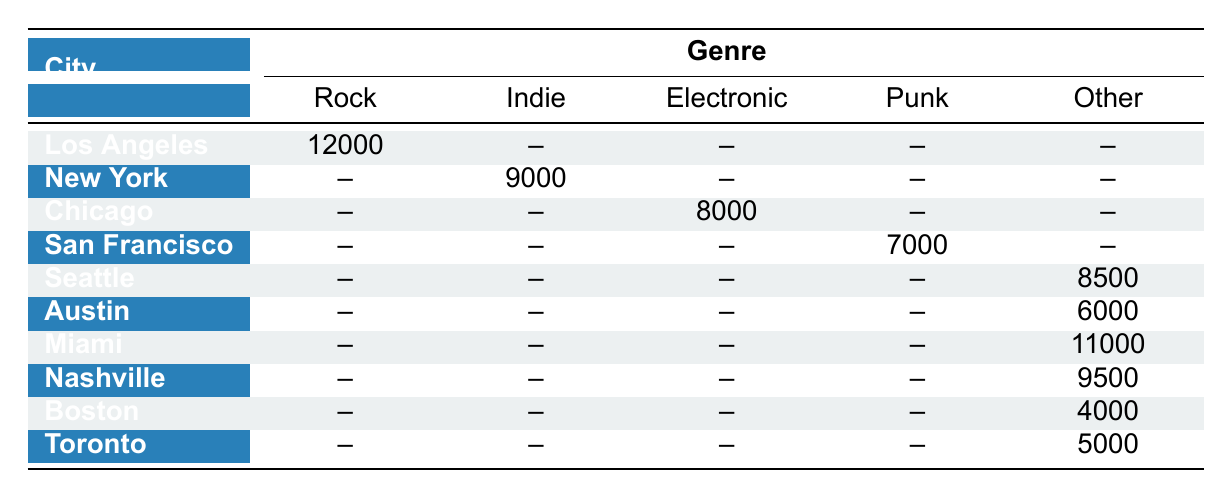What is the concert attendance for Los Angeles in the Rock genre? According to the table, Los Angeles has an attendance of 12000 for the Rock genre.
Answer: 12000 Which city had the lowest concert attendance? By looking at the table, Boston had the lowest attendance with 4000.
Answer: 4000 Is there any city listed for the Punk genre? Yes, San Francisco is the only city listed for the Punk genre, with an attendance of 7000.
Answer: Yes What is the total concert attendance for cities that have genres listed as 'Other'? Only two entries fall under the 'Other' category: Seattle (8500) and Austin (6000), summing these gives 8500 + 6000 = 14500.
Answer: 14500 Which city had higher attendance: Miami or Nashville? Miami had an attendance of 11000, while Nashville had 9500. Therefore, Miami had higher attendance.
Answer: Miami What is the difference in attendance between New York's Indie and Miami's Hip-Hop genre? New York's attendance is 9000 for the Indie genre, and Miami's is 11000 for Hip-Hop. The difference is 11000 - 9000 = 2000.
Answer: 2000 Are there any cities with an attendance of more than 10000? Yes, there are two cities: Los Angeles (12000) and Miami (11000) with attendance greater than 10000.
Answer: Yes What is the average concert attendance across all genres and cities? The total attendance across all cities is 12000 + 9000 + 8000 + 7000 + 8500 + 6000 + 11000 + 9500 + 4000 + 5000 = 76500. With 10 entries, the average attendance is 76500 / 10 = 7650.
Answer: 7650 Which genre has the highest attendance and what is that attendance? The Rock genre, represented by Los Angeles, has the highest attendance of 12000.
Answer: 12000 